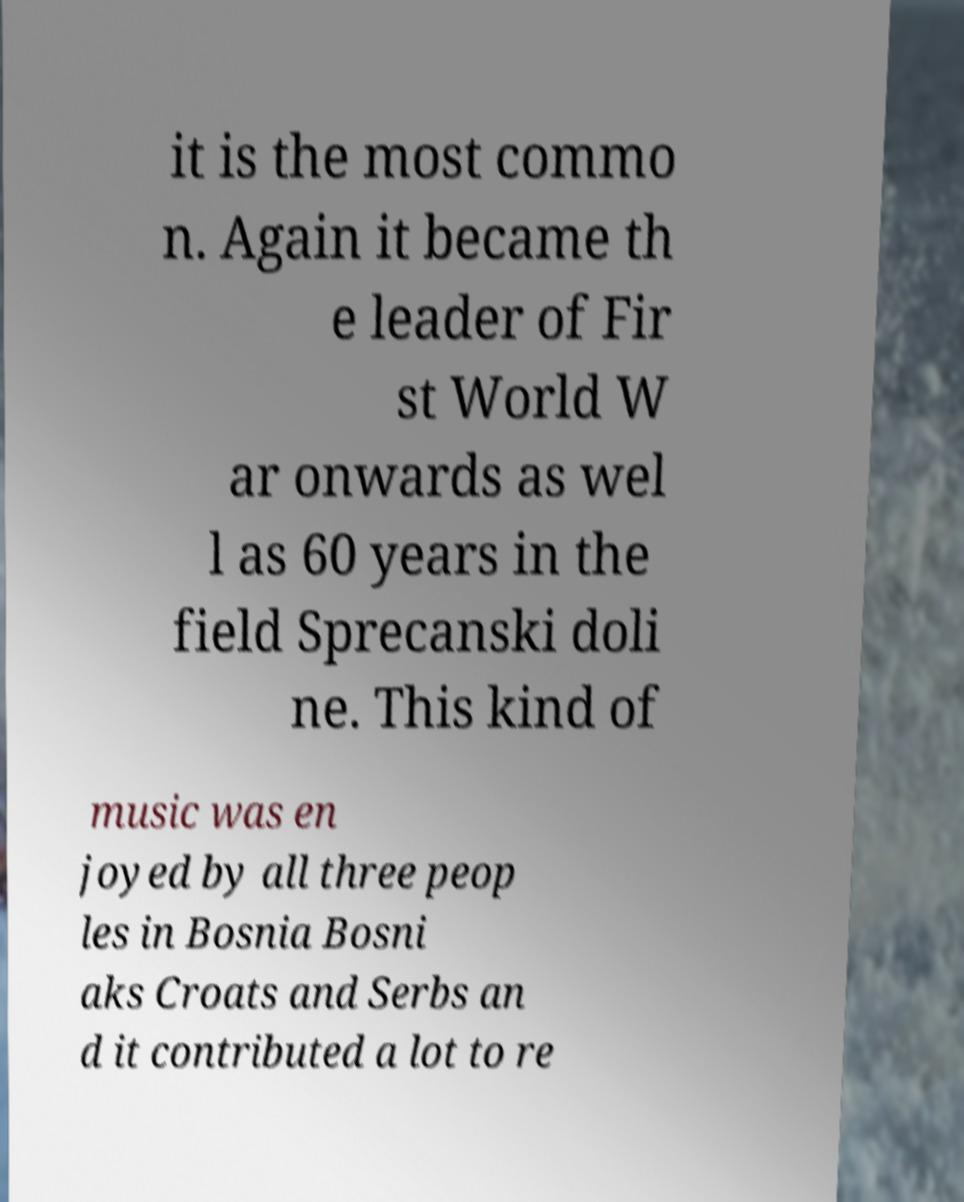Can you accurately transcribe the text from the provided image for me? it is the most commo n. Again it became th e leader of Fir st World W ar onwards as wel l as 60 years in the field Sprecanski doli ne. This kind of music was en joyed by all three peop les in Bosnia Bosni aks Croats and Serbs an d it contributed a lot to re 